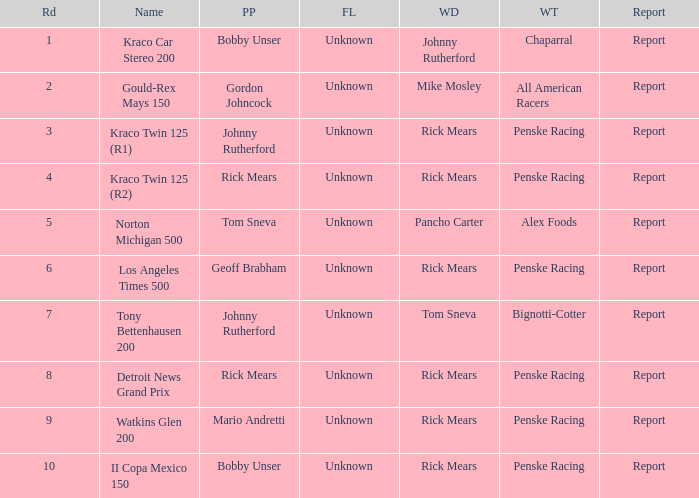The winning team of the race, los angeles times 500 is who? Penske Racing. 